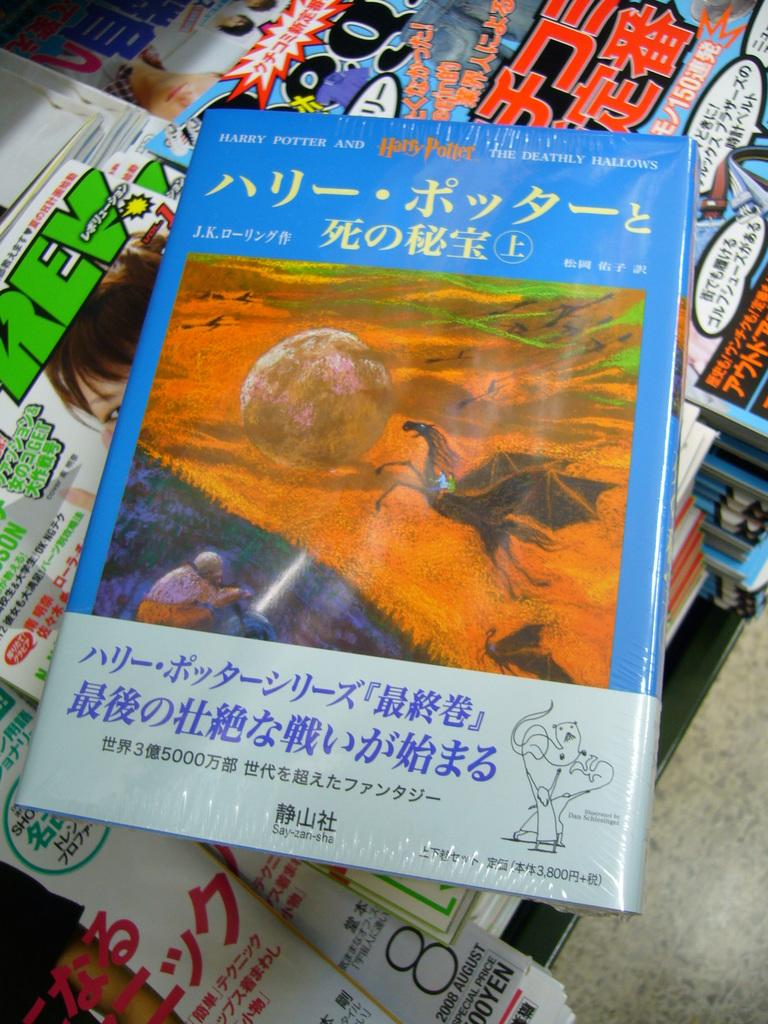<image>
Provide a brief description of the given image. A pile of books in Chinese including one about Harry Potter. 